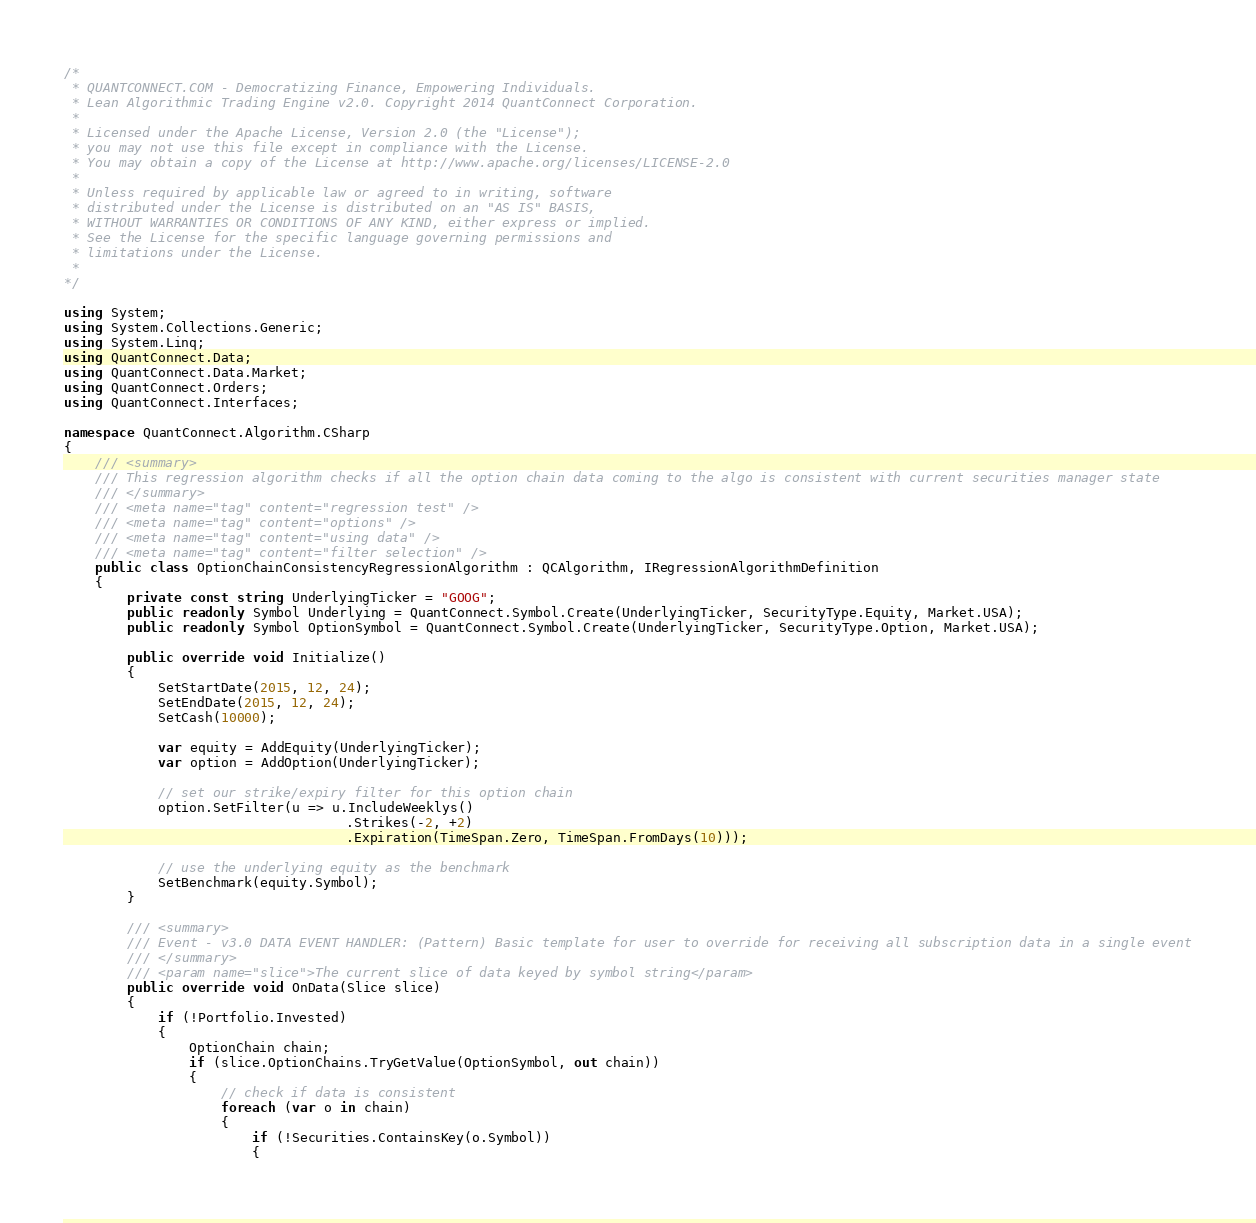<code> <loc_0><loc_0><loc_500><loc_500><_C#_>/*
 * QUANTCONNECT.COM - Democratizing Finance, Empowering Individuals.
 * Lean Algorithmic Trading Engine v2.0. Copyright 2014 QuantConnect Corporation.
 *
 * Licensed under the Apache License, Version 2.0 (the "License");
 * you may not use this file except in compliance with the License.
 * You may obtain a copy of the License at http://www.apache.org/licenses/LICENSE-2.0
 *
 * Unless required by applicable law or agreed to in writing, software
 * distributed under the License is distributed on an "AS IS" BASIS,
 * WITHOUT WARRANTIES OR CONDITIONS OF ANY KIND, either express or implied.
 * See the License for the specific language governing permissions and
 * limitations under the License.
 *
*/

using System;
using System.Collections.Generic;
using System.Linq;
using QuantConnect.Data;
using QuantConnect.Data.Market;
using QuantConnect.Orders;
using QuantConnect.Interfaces;

namespace QuantConnect.Algorithm.CSharp
{
    /// <summary>
    /// This regression algorithm checks if all the option chain data coming to the algo is consistent with current securities manager state
    /// </summary>
    /// <meta name="tag" content="regression test" />
    /// <meta name="tag" content="options" />
    /// <meta name="tag" content="using data" />
    /// <meta name="tag" content="filter selection" />
    public class OptionChainConsistencyRegressionAlgorithm : QCAlgorithm, IRegressionAlgorithmDefinition
    {
        private const string UnderlyingTicker = "GOOG";
        public readonly Symbol Underlying = QuantConnect.Symbol.Create(UnderlyingTicker, SecurityType.Equity, Market.USA);
        public readonly Symbol OptionSymbol = QuantConnect.Symbol.Create(UnderlyingTicker, SecurityType.Option, Market.USA);

        public override void Initialize()
        {
            SetStartDate(2015, 12, 24);
            SetEndDate(2015, 12, 24);
            SetCash(10000);

            var equity = AddEquity(UnderlyingTicker);
            var option = AddOption(UnderlyingTicker);

            // set our strike/expiry filter for this option chain
            option.SetFilter(u => u.IncludeWeeklys()
                                    .Strikes(-2, +2)
                                    .Expiration(TimeSpan.Zero, TimeSpan.FromDays(10)));

            // use the underlying equity as the benchmark
            SetBenchmark(equity.Symbol);
        }

        /// <summary>
        /// Event - v3.0 DATA EVENT HANDLER: (Pattern) Basic template for user to override for receiving all subscription data in a single event
        /// </summary>
        /// <param name="slice">The current slice of data keyed by symbol string</param>
        public override void OnData(Slice slice)
        {
            if (!Portfolio.Invested)
            {
                OptionChain chain;
                if (slice.OptionChains.TryGetValue(OptionSymbol, out chain))
                {
                    // check if data is consistent
                    foreach (var o in chain)
                    {
                        if (!Securities.ContainsKey(o.Symbol))
                        {</code> 